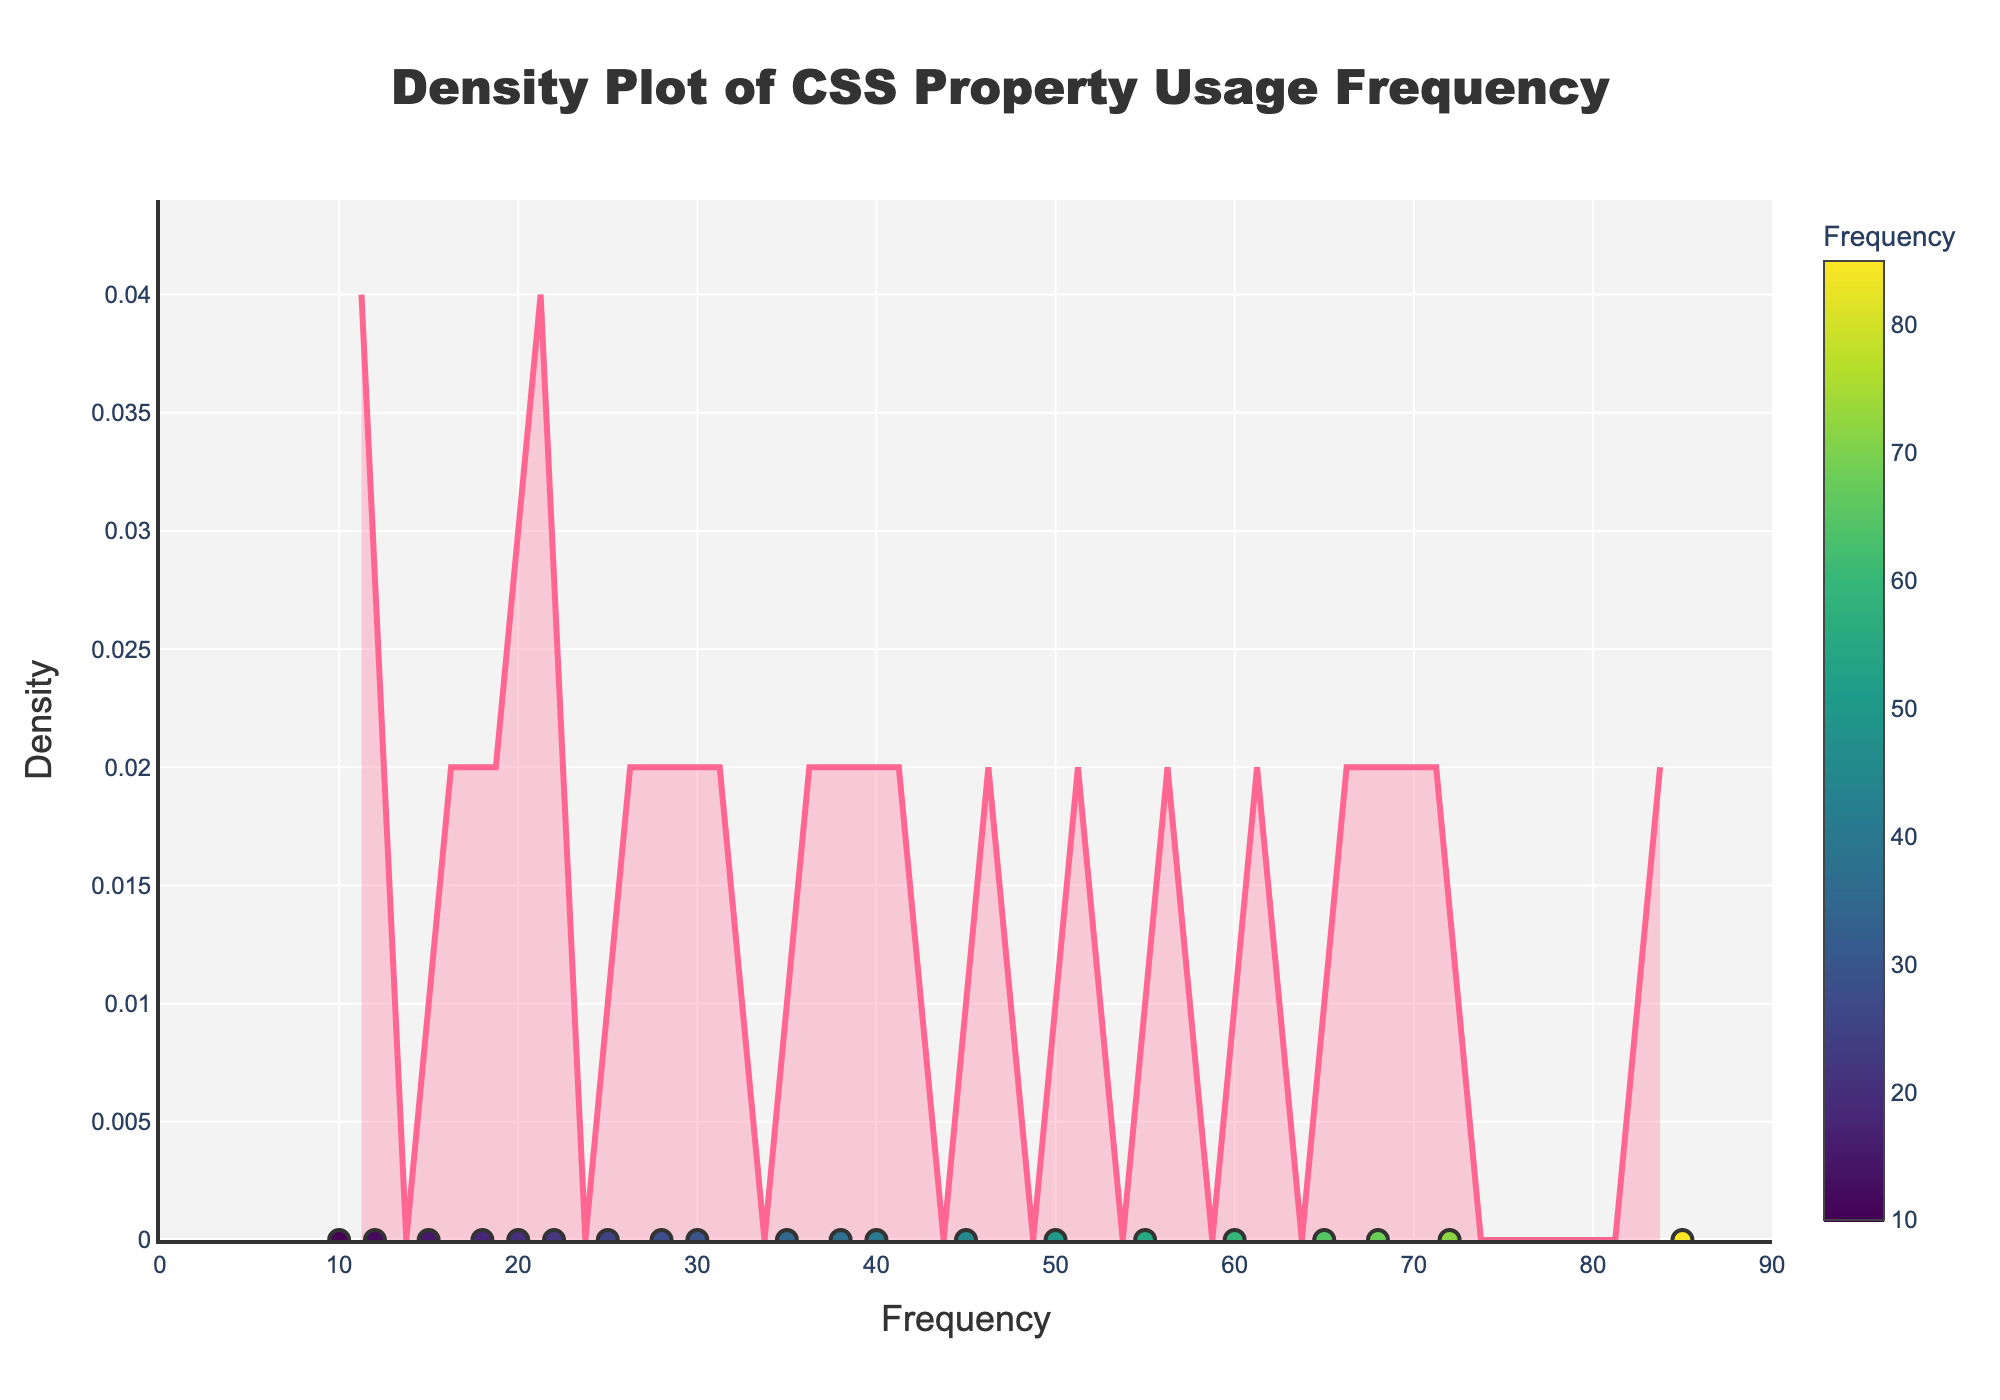What is the title of the figure? The title is located at the top center of the figure and reads "Density Plot of CSS Property Usage Frequency".
Answer: Density Plot of CSS Property Usage Frequency What is the range of frequencies shown on the x-axis? The x-axis ranges from 0 to 90, as indicated by the ticks and labels on the axis.
Answer: 0 to 90 Which CSS property has the highest usage frequency? In the scatter plot section, the "color" property has the highest value at 85, which is the peak point on the x-axis with the highest density.
Answer: color What is the color used for the density plot line? The density plot line is represented with a pinkish color. This can be described as a bright pink or magenta color in natural language seen on the plot.
Answer: pink How many unique data points are represented by the scatter plot markers? Each CSS property provides a unique data point in the scatter plot. Since the dataset includes 20 CSS properties, there are 20 unique data points.
Answer: 20 What is the frequency of the CSS property `font-size`? To find this, look for the data point representing `font-size` in the scatter plot. It is marked at 72 on the x-axis.
Answer: 72 What is the shape of the distribution based on the density plot? The density plot shape shows how the frequencies are distributed. It's a single peak near lower frequencies which then tapers off as the frequency increases.
Answer: Single peak, right-skewed What is the minimum frequency value of the CSS properties displayed? The minimum frequency value visible in the scatter plot is 10, which corresponds to the `overflow` property on the x-axis.
Answer: 10 Which frequency range has the highest density? The highest density is observed around the frequency range of 50 to 90, where the density curve reaches its peak. This can be seen in the hump of the density line.
Answer: 50 to 90 Compare the density at a frequency of 35 and 55, which is higher? The density plot shows higher density around 55 compared to 35. This is visible by comparing the heights of the density curve at these points on the x-axis.
Answer: 55 